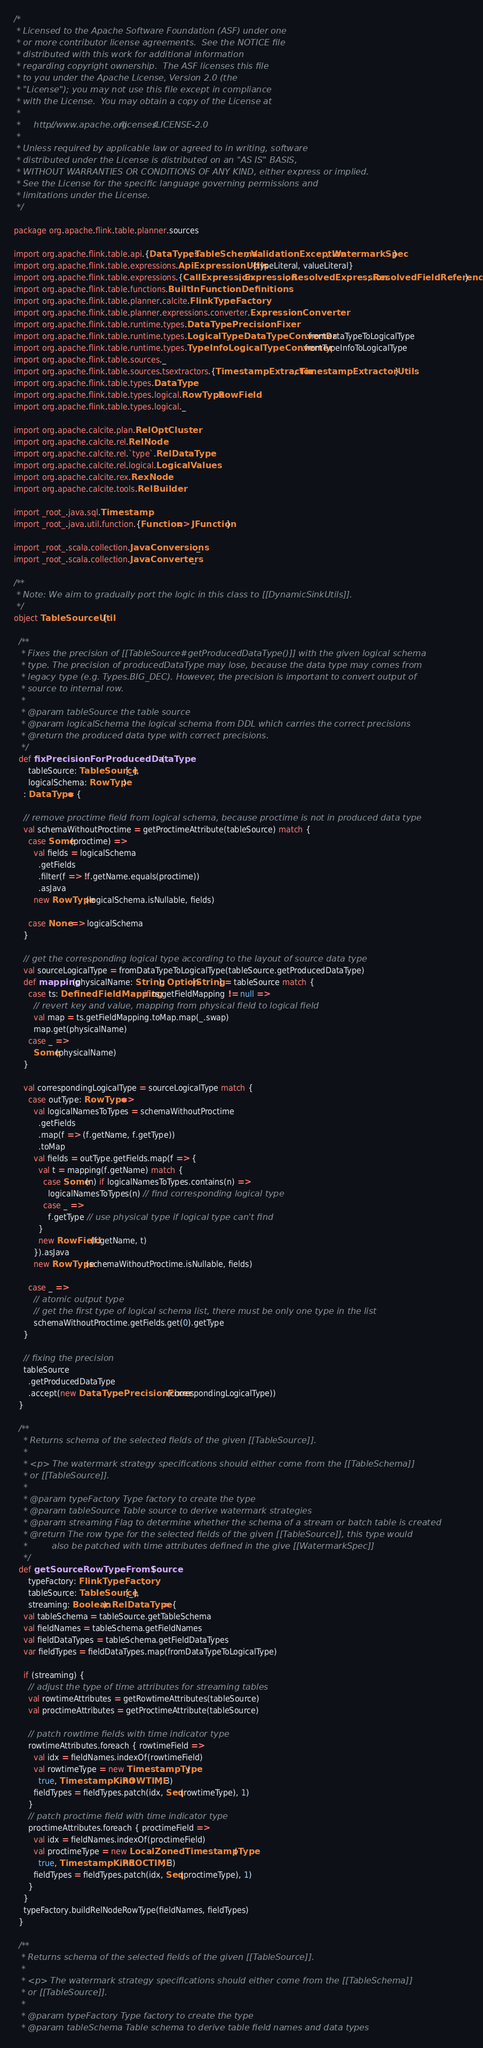Convert code to text. <code><loc_0><loc_0><loc_500><loc_500><_Scala_>/*
 * Licensed to the Apache Software Foundation (ASF) under one
 * or more contributor license agreements.  See the NOTICE file
 * distributed with this work for additional information
 * regarding copyright ownership.  The ASF licenses this file
 * to you under the Apache License, Version 2.0 (the
 * "License"); you may not use this file except in compliance
 * with the License.  You may obtain a copy of the License at
 *
 *     http://www.apache.org/licenses/LICENSE-2.0
 *
 * Unless required by applicable law or agreed to in writing, software
 * distributed under the License is distributed on an "AS IS" BASIS,
 * WITHOUT WARRANTIES OR CONDITIONS OF ANY KIND, either express or implied.
 * See the License for the specific language governing permissions and
 * limitations under the License.
 */

package org.apache.flink.table.planner.sources

import org.apache.flink.table.api.{DataTypes, TableSchema, ValidationException, WatermarkSpec}
import org.apache.flink.table.expressions.ApiExpressionUtils.{typeLiteral, valueLiteral}
import org.apache.flink.table.expressions.{CallExpression, Expression, ResolvedExpression, ResolvedFieldReference}
import org.apache.flink.table.functions.BuiltInFunctionDefinitions
import org.apache.flink.table.planner.calcite.FlinkTypeFactory
import org.apache.flink.table.planner.expressions.converter.ExpressionConverter
import org.apache.flink.table.runtime.types.DataTypePrecisionFixer
import org.apache.flink.table.runtime.types.LogicalTypeDataTypeConverter.fromDataTypeToLogicalType
import org.apache.flink.table.runtime.types.TypeInfoLogicalTypeConverter.fromTypeInfoToLogicalType
import org.apache.flink.table.sources._
import org.apache.flink.table.sources.tsextractors.{TimestampExtractor, TimestampExtractorUtils}
import org.apache.flink.table.types.DataType
import org.apache.flink.table.types.logical.RowType.RowField
import org.apache.flink.table.types.logical._

import org.apache.calcite.plan.RelOptCluster
import org.apache.calcite.rel.RelNode
import org.apache.calcite.rel.`type`.RelDataType
import org.apache.calcite.rel.logical.LogicalValues
import org.apache.calcite.rex.RexNode
import org.apache.calcite.tools.RelBuilder

import _root_.java.sql.Timestamp
import _root_.java.util.function.{Function => JFunction}

import _root_.scala.collection.JavaConversions._
import _root_.scala.collection.JavaConverters._

/**
 * Note: We aim to gradually port the logic in this class to [[DynamicSinkUtils]].
 */
object TableSourceUtil {

  /**
   * Fixes the precision of [[TableSource#getProducedDataType()]] with the given logical schema
   * type. The precision of producedDataType may lose, because the data type may comes from
   * legacy type (e.g. Types.BIG_DEC). However, the precision is important to convert output of
   * source to internal row.
   *
   * @param tableSource the table source
   * @param logicalSchema the logical schema from DDL which carries the correct precisions
   * @return the produced data type with correct precisions.
   */
  def fixPrecisionForProducedDataType(
      tableSource: TableSource[_],
      logicalSchema: RowType)
    : DataType = {

    // remove proctime field from logical schema, because proctime is not in produced data type
    val schemaWithoutProctime = getProctimeAttribute(tableSource) match {
      case Some(proctime) =>
        val fields = logicalSchema
          .getFields
          .filter(f => !f.getName.equals(proctime))
          .asJava
        new RowType(logicalSchema.isNullable, fields)

      case None => logicalSchema
    }

    // get the corresponding logical type according to the layout of source data type
    val sourceLogicalType = fromDataTypeToLogicalType(tableSource.getProducedDataType)
    def mapping(physicalName: String): Option[String] = tableSource match {
      case ts: DefinedFieldMapping if ts.getFieldMapping != null =>
        // revert key and value, mapping from physical field to logical field
        val map = ts.getFieldMapping.toMap.map(_.swap)
        map.get(physicalName)
      case _ =>
        Some(physicalName)
    }

    val correspondingLogicalType = sourceLogicalType match {
      case outType: RowType =>
        val logicalNamesToTypes = schemaWithoutProctime
          .getFields
          .map(f => (f.getName, f.getType))
          .toMap
        val fields = outType.getFields.map(f => {
          val t = mapping(f.getName) match {
            case Some(n) if logicalNamesToTypes.contains(n) =>
              logicalNamesToTypes(n) // find corresponding logical type
            case _ =>
              f.getType // use physical type if logical type can't find
          }
          new RowField(f.getName, t)
        }).asJava
        new RowType(schemaWithoutProctime.isNullable, fields)

      case _ =>
        // atomic output type
        // get the first type of logical schema list, there must be only one type in the list
        schemaWithoutProctime.getFields.get(0).getType
    }

    // fixing the precision
    tableSource
      .getProducedDataType
      .accept(new DataTypePrecisionFixer(correspondingLogicalType))
  }

  /**
    * Returns schema of the selected fields of the given [[TableSource]].
    *
    * <p> The watermark strategy specifications should either come from the [[TableSchema]]
    * or [[TableSource]].
    *
    * @param typeFactory Type factory to create the type
    * @param tableSource Table source to derive watermark strategies
    * @param streaming Flag to determine whether the schema of a stream or batch table is created
    * @return The row type for the selected fields of the given [[TableSource]], this type would
    *         also be patched with time attributes defined in the give [[WatermarkSpec]]
    */
  def getSourceRowTypeFromSource(
      typeFactory: FlinkTypeFactory,
      tableSource: TableSource[_],
      streaming: Boolean): RelDataType = {
    val tableSchema = tableSource.getTableSchema
    val fieldNames = tableSchema.getFieldNames
    val fieldDataTypes = tableSchema.getFieldDataTypes
    var fieldTypes = fieldDataTypes.map(fromDataTypeToLogicalType)

    if (streaming) {
      // adjust the type of time attributes for streaming tables
      val rowtimeAttributes = getRowtimeAttributes(tableSource)
      val proctimeAttributes = getProctimeAttribute(tableSource)

      // patch rowtime fields with time indicator type
      rowtimeAttributes.foreach { rowtimeField =>
        val idx = fieldNames.indexOf(rowtimeField)
        val rowtimeType = new TimestampType(
          true, TimestampKind.ROWTIME, 3)
        fieldTypes = fieldTypes.patch(idx, Seq(rowtimeType), 1)
      }
      // patch proctime field with time indicator type
      proctimeAttributes.foreach { proctimeField =>
        val idx = fieldNames.indexOf(proctimeField)
        val proctimeType = new LocalZonedTimestampType(
          true, TimestampKind.PROCTIME, 3)
        fieldTypes = fieldTypes.patch(idx, Seq(proctimeType), 1)
      }
    }
    typeFactory.buildRelNodeRowType(fieldNames, fieldTypes)
  }

  /**
   * Returns schema of the selected fields of the given [[TableSource]].
   *
   * <p> The watermark strategy specifications should either come from the [[TableSchema]]
   * or [[TableSource]].
   *
   * @param typeFactory Type factory to create the type
   * @param tableSchema Table schema to derive table field names and data types</code> 